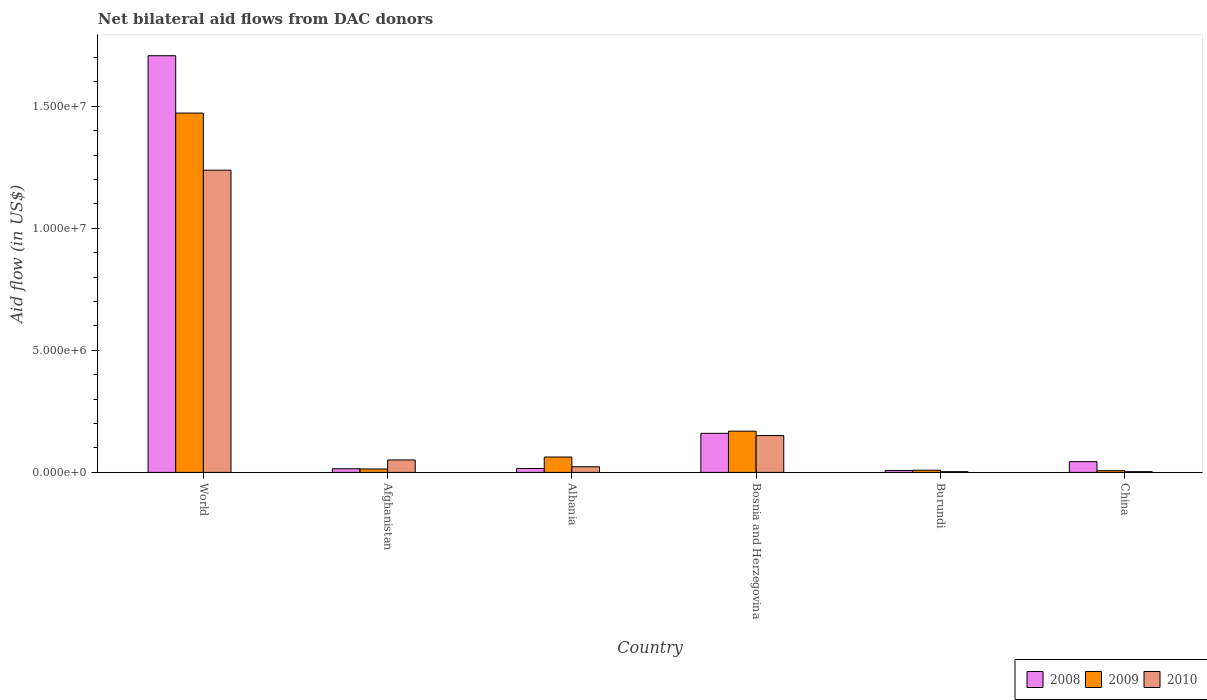How many different coloured bars are there?
Your answer should be compact. 3. Are the number of bars on each tick of the X-axis equal?
Provide a succinct answer. Yes. How many bars are there on the 1st tick from the right?
Make the answer very short. 3. What is the label of the 6th group of bars from the left?
Ensure brevity in your answer.  China. In how many cases, is the number of bars for a given country not equal to the number of legend labels?
Ensure brevity in your answer.  0. What is the net bilateral aid flow in 2009 in China?
Ensure brevity in your answer.  7.00e+04. Across all countries, what is the maximum net bilateral aid flow in 2010?
Your response must be concise. 1.24e+07. Across all countries, what is the minimum net bilateral aid flow in 2008?
Your answer should be very brief. 8.00e+04. In which country was the net bilateral aid flow in 2010 maximum?
Provide a succinct answer. World. In which country was the net bilateral aid flow in 2008 minimum?
Keep it short and to the point. Burundi. What is the total net bilateral aid flow in 2010 in the graph?
Your answer should be very brief. 1.47e+07. What is the difference between the net bilateral aid flow in 2009 in Bosnia and Herzegovina and that in Burundi?
Ensure brevity in your answer.  1.60e+06. What is the difference between the net bilateral aid flow in 2008 in Burundi and the net bilateral aid flow in 2010 in Bosnia and Herzegovina?
Offer a very short reply. -1.43e+06. What is the average net bilateral aid flow in 2008 per country?
Ensure brevity in your answer.  3.25e+06. In how many countries, is the net bilateral aid flow in 2008 greater than 3000000 US$?
Keep it short and to the point. 1. What is the ratio of the net bilateral aid flow in 2010 in Bosnia and Herzegovina to that in World?
Your answer should be very brief. 0.12. Is the net bilateral aid flow in 2010 in Bosnia and Herzegovina less than that in World?
Your answer should be very brief. Yes. What is the difference between the highest and the second highest net bilateral aid flow in 2008?
Your answer should be very brief. 1.55e+07. What is the difference between the highest and the lowest net bilateral aid flow in 2009?
Make the answer very short. 1.46e+07. Is the sum of the net bilateral aid flow in 2009 in Albania and Burundi greater than the maximum net bilateral aid flow in 2008 across all countries?
Provide a short and direct response. No. What does the 2nd bar from the left in China represents?
Offer a terse response. 2009. What does the 3rd bar from the right in World represents?
Offer a terse response. 2008. How many bars are there?
Give a very brief answer. 18. What is the difference between two consecutive major ticks on the Y-axis?
Your answer should be very brief. 5.00e+06. Does the graph contain any zero values?
Offer a terse response. No. How are the legend labels stacked?
Offer a terse response. Horizontal. What is the title of the graph?
Your answer should be compact. Net bilateral aid flows from DAC donors. What is the label or title of the Y-axis?
Keep it short and to the point. Aid flow (in US$). What is the Aid flow (in US$) of 2008 in World?
Give a very brief answer. 1.71e+07. What is the Aid flow (in US$) of 2009 in World?
Your answer should be compact. 1.47e+07. What is the Aid flow (in US$) in 2010 in World?
Provide a short and direct response. 1.24e+07. What is the Aid flow (in US$) of 2008 in Afghanistan?
Your answer should be compact. 1.50e+05. What is the Aid flow (in US$) of 2010 in Afghanistan?
Keep it short and to the point. 5.10e+05. What is the Aid flow (in US$) of 2009 in Albania?
Offer a terse response. 6.30e+05. What is the Aid flow (in US$) of 2010 in Albania?
Offer a terse response. 2.30e+05. What is the Aid flow (in US$) of 2008 in Bosnia and Herzegovina?
Your response must be concise. 1.60e+06. What is the Aid flow (in US$) of 2009 in Bosnia and Herzegovina?
Your answer should be compact. 1.69e+06. What is the Aid flow (in US$) in 2010 in Bosnia and Herzegovina?
Offer a very short reply. 1.51e+06. What is the Aid flow (in US$) of 2009 in Burundi?
Your answer should be compact. 9.00e+04. What is the Aid flow (in US$) of 2010 in Burundi?
Ensure brevity in your answer.  3.00e+04. What is the Aid flow (in US$) in 2008 in China?
Your answer should be very brief. 4.40e+05. What is the Aid flow (in US$) of 2009 in China?
Provide a succinct answer. 7.00e+04. Across all countries, what is the maximum Aid flow (in US$) in 2008?
Your answer should be compact. 1.71e+07. Across all countries, what is the maximum Aid flow (in US$) in 2009?
Provide a short and direct response. 1.47e+07. Across all countries, what is the maximum Aid flow (in US$) in 2010?
Offer a terse response. 1.24e+07. Across all countries, what is the minimum Aid flow (in US$) of 2008?
Provide a short and direct response. 8.00e+04. What is the total Aid flow (in US$) of 2008 in the graph?
Make the answer very short. 1.95e+07. What is the total Aid flow (in US$) of 2009 in the graph?
Offer a terse response. 1.73e+07. What is the total Aid flow (in US$) of 2010 in the graph?
Provide a succinct answer. 1.47e+07. What is the difference between the Aid flow (in US$) in 2008 in World and that in Afghanistan?
Your answer should be very brief. 1.69e+07. What is the difference between the Aid flow (in US$) in 2009 in World and that in Afghanistan?
Make the answer very short. 1.46e+07. What is the difference between the Aid flow (in US$) in 2010 in World and that in Afghanistan?
Your response must be concise. 1.19e+07. What is the difference between the Aid flow (in US$) of 2008 in World and that in Albania?
Your answer should be compact. 1.69e+07. What is the difference between the Aid flow (in US$) in 2009 in World and that in Albania?
Your answer should be very brief. 1.41e+07. What is the difference between the Aid flow (in US$) in 2010 in World and that in Albania?
Provide a short and direct response. 1.22e+07. What is the difference between the Aid flow (in US$) of 2008 in World and that in Bosnia and Herzegovina?
Keep it short and to the point. 1.55e+07. What is the difference between the Aid flow (in US$) of 2009 in World and that in Bosnia and Herzegovina?
Offer a terse response. 1.30e+07. What is the difference between the Aid flow (in US$) of 2010 in World and that in Bosnia and Herzegovina?
Your answer should be compact. 1.09e+07. What is the difference between the Aid flow (in US$) of 2008 in World and that in Burundi?
Provide a short and direct response. 1.70e+07. What is the difference between the Aid flow (in US$) of 2009 in World and that in Burundi?
Give a very brief answer. 1.46e+07. What is the difference between the Aid flow (in US$) of 2010 in World and that in Burundi?
Your answer should be very brief. 1.24e+07. What is the difference between the Aid flow (in US$) in 2008 in World and that in China?
Offer a terse response. 1.66e+07. What is the difference between the Aid flow (in US$) of 2009 in World and that in China?
Ensure brevity in your answer.  1.46e+07. What is the difference between the Aid flow (in US$) of 2010 in World and that in China?
Give a very brief answer. 1.24e+07. What is the difference between the Aid flow (in US$) of 2008 in Afghanistan and that in Albania?
Provide a short and direct response. -10000. What is the difference between the Aid flow (in US$) in 2009 in Afghanistan and that in Albania?
Keep it short and to the point. -4.90e+05. What is the difference between the Aid flow (in US$) in 2008 in Afghanistan and that in Bosnia and Herzegovina?
Make the answer very short. -1.45e+06. What is the difference between the Aid flow (in US$) of 2009 in Afghanistan and that in Bosnia and Herzegovina?
Your answer should be compact. -1.55e+06. What is the difference between the Aid flow (in US$) in 2010 in Afghanistan and that in Bosnia and Herzegovina?
Provide a short and direct response. -1.00e+06. What is the difference between the Aid flow (in US$) in 2008 in Afghanistan and that in Burundi?
Provide a succinct answer. 7.00e+04. What is the difference between the Aid flow (in US$) of 2009 in Afghanistan and that in Burundi?
Provide a succinct answer. 5.00e+04. What is the difference between the Aid flow (in US$) in 2009 in Afghanistan and that in China?
Provide a short and direct response. 7.00e+04. What is the difference between the Aid flow (in US$) in 2010 in Afghanistan and that in China?
Your response must be concise. 4.80e+05. What is the difference between the Aid flow (in US$) in 2008 in Albania and that in Bosnia and Herzegovina?
Your answer should be very brief. -1.44e+06. What is the difference between the Aid flow (in US$) of 2009 in Albania and that in Bosnia and Herzegovina?
Offer a very short reply. -1.06e+06. What is the difference between the Aid flow (in US$) of 2010 in Albania and that in Bosnia and Herzegovina?
Your response must be concise. -1.28e+06. What is the difference between the Aid flow (in US$) of 2008 in Albania and that in Burundi?
Ensure brevity in your answer.  8.00e+04. What is the difference between the Aid flow (in US$) of 2009 in Albania and that in Burundi?
Ensure brevity in your answer.  5.40e+05. What is the difference between the Aid flow (in US$) of 2010 in Albania and that in Burundi?
Provide a succinct answer. 2.00e+05. What is the difference between the Aid flow (in US$) of 2008 in Albania and that in China?
Provide a short and direct response. -2.80e+05. What is the difference between the Aid flow (in US$) of 2009 in Albania and that in China?
Make the answer very short. 5.60e+05. What is the difference between the Aid flow (in US$) in 2010 in Albania and that in China?
Your response must be concise. 2.00e+05. What is the difference between the Aid flow (in US$) in 2008 in Bosnia and Herzegovina and that in Burundi?
Ensure brevity in your answer.  1.52e+06. What is the difference between the Aid flow (in US$) in 2009 in Bosnia and Herzegovina and that in Burundi?
Ensure brevity in your answer.  1.60e+06. What is the difference between the Aid flow (in US$) of 2010 in Bosnia and Herzegovina and that in Burundi?
Your answer should be very brief. 1.48e+06. What is the difference between the Aid flow (in US$) of 2008 in Bosnia and Herzegovina and that in China?
Provide a short and direct response. 1.16e+06. What is the difference between the Aid flow (in US$) of 2009 in Bosnia and Herzegovina and that in China?
Provide a short and direct response. 1.62e+06. What is the difference between the Aid flow (in US$) of 2010 in Bosnia and Herzegovina and that in China?
Ensure brevity in your answer.  1.48e+06. What is the difference between the Aid flow (in US$) of 2008 in Burundi and that in China?
Offer a very short reply. -3.60e+05. What is the difference between the Aid flow (in US$) of 2009 in Burundi and that in China?
Provide a short and direct response. 2.00e+04. What is the difference between the Aid flow (in US$) in 2008 in World and the Aid flow (in US$) in 2009 in Afghanistan?
Offer a very short reply. 1.69e+07. What is the difference between the Aid flow (in US$) of 2008 in World and the Aid flow (in US$) of 2010 in Afghanistan?
Provide a short and direct response. 1.66e+07. What is the difference between the Aid flow (in US$) of 2009 in World and the Aid flow (in US$) of 2010 in Afghanistan?
Your response must be concise. 1.42e+07. What is the difference between the Aid flow (in US$) of 2008 in World and the Aid flow (in US$) of 2009 in Albania?
Your response must be concise. 1.64e+07. What is the difference between the Aid flow (in US$) of 2008 in World and the Aid flow (in US$) of 2010 in Albania?
Provide a succinct answer. 1.68e+07. What is the difference between the Aid flow (in US$) of 2009 in World and the Aid flow (in US$) of 2010 in Albania?
Your response must be concise. 1.45e+07. What is the difference between the Aid flow (in US$) in 2008 in World and the Aid flow (in US$) in 2009 in Bosnia and Herzegovina?
Your response must be concise. 1.54e+07. What is the difference between the Aid flow (in US$) of 2008 in World and the Aid flow (in US$) of 2010 in Bosnia and Herzegovina?
Your answer should be compact. 1.56e+07. What is the difference between the Aid flow (in US$) of 2009 in World and the Aid flow (in US$) of 2010 in Bosnia and Herzegovina?
Your answer should be compact. 1.32e+07. What is the difference between the Aid flow (in US$) of 2008 in World and the Aid flow (in US$) of 2009 in Burundi?
Make the answer very short. 1.70e+07. What is the difference between the Aid flow (in US$) of 2008 in World and the Aid flow (in US$) of 2010 in Burundi?
Your answer should be very brief. 1.70e+07. What is the difference between the Aid flow (in US$) of 2009 in World and the Aid flow (in US$) of 2010 in Burundi?
Ensure brevity in your answer.  1.47e+07. What is the difference between the Aid flow (in US$) of 2008 in World and the Aid flow (in US$) of 2009 in China?
Offer a terse response. 1.70e+07. What is the difference between the Aid flow (in US$) in 2008 in World and the Aid flow (in US$) in 2010 in China?
Provide a short and direct response. 1.70e+07. What is the difference between the Aid flow (in US$) of 2009 in World and the Aid flow (in US$) of 2010 in China?
Your response must be concise. 1.47e+07. What is the difference between the Aid flow (in US$) in 2008 in Afghanistan and the Aid flow (in US$) in 2009 in Albania?
Your answer should be very brief. -4.80e+05. What is the difference between the Aid flow (in US$) in 2008 in Afghanistan and the Aid flow (in US$) in 2010 in Albania?
Keep it short and to the point. -8.00e+04. What is the difference between the Aid flow (in US$) in 2009 in Afghanistan and the Aid flow (in US$) in 2010 in Albania?
Make the answer very short. -9.00e+04. What is the difference between the Aid flow (in US$) in 2008 in Afghanistan and the Aid flow (in US$) in 2009 in Bosnia and Herzegovina?
Give a very brief answer. -1.54e+06. What is the difference between the Aid flow (in US$) of 2008 in Afghanistan and the Aid flow (in US$) of 2010 in Bosnia and Herzegovina?
Your answer should be very brief. -1.36e+06. What is the difference between the Aid flow (in US$) in 2009 in Afghanistan and the Aid flow (in US$) in 2010 in Bosnia and Herzegovina?
Provide a succinct answer. -1.37e+06. What is the difference between the Aid flow (in US$) in 2008 in Afghanistan and the Aid flow (in US$) in 2009 in Burundi?
Offer a terse response. 6.00e+04. What is the difference between the Aid flow (in US$) in 2009 in Afghanistan and the Aid flow (in US$) in 2010 in China?
Your answer should be very brief. 1.10e+05. What is the difference between the Aid flow (in US$) of 2008 in Albania and the Aid flow (in US$) of 2009 in Bosnia and Herzegovina?
Your answer should be compact. -1.53e+06. What is the difference between the Aid flow (in US$) of 2008 in Albania and the Aid flow (in US$) of 2010 in Bosnia and Herzegovina?
Provide a succinct answer. -1.35e+06. What is the difference between the Aid flow (in US$) in 2009 in Albania and the Aid flow (in US$) in 2010 in Bosnia and Herzegovina?
Ensure brevity in your answer.  -8.80e+05. What is the difference between the Aid flow (in US$) of 2008 in Albania and the Aid flow (in US$) of 2009 in Burundi?
Your answer should be very brief. 7.00e+04. What is the difference between the Aid flow (in US$) in 2008 in Albania and the Aid flow (in US$) in 2009 in China?
Your answer should be very brief. 9.00e+04. What is the difference between the Aid flow (in US$) of 2009 in Albania and the Aid flow (in US$) of 2010 in China?
Give a very brief answer. 6.00e+05. What is the difference between the Aid flow (in US$) of 2008 in Bosnia and Herzegovina and the Aid flow (in US$) of 2009 in Burundi?
Your answer should be compact. 1.51e+06. What is the difference between the Aid flow (in US$) in 2008 in Bosnia and Herzegovina and the Aid flow (in US$) in 2010 in Burundi?
Your response must be concise. 1.57e+06. What is the difference between the Aid flow (in US$) in 2009 in Bosnia and Herzegovina and the Aid flow (in US$) in 2010 in Burundi?
Give a very brief answer. 1.66e+06. What is the difference between the Aid flow (in US$) in 2008 in Bosnia and Herzegovina and the Aid flow (in US$) in 2009 in China?
Make the answer very short. 1.53e+06. What is the difference between the Aid flow (in US$) of 2008 in Bosnia and Herzegovina and the Aid flow (in US$) of 2010 in China?
Your answer should be compact. 1.57e+06. What is the difference between the Aid flow (in US$) of 2009 in Bosnia and Herzegovina and the Aid flow (in US$) of 2010 in China?
Offer a very short reply. 1.66e+06. What is the difference between the Aid flow (in US$) in 2008 in Burundi and the Aid flow (in US$) in 2009 in China?
Ensure brevity in your answer.  10000. What is the difference between the Aid flow (in US$) of 2009 in Burundi and the Aid flow (in US$) of 2010 in China?
Ensure brevity in your answer.  6.00e+04. What is the average Aid flow (in US$) of 2008 per country?
Provide a short and direct response. 3.25e+06. What is the average Aid flow (in US$) of 2009 per country?
Offer a terse response. 2.89e+06. What is the average Aid flow (in US$) of 2010 per country?
Your answer should be compact. 2.45e+06. What is the difference between the Aid flow (in US$) in 2008 and Aid flow (in US$) in 2009 in World?
Provide a succinct answer. 2.35e+06. What is the difference between the Aid flow (in US$) in 2008 and Aid flow (in US$) in 2010 in World?
Ensure brevity in your answer.  4.69e+06. What is the difference between the Aid flow (in US$) in 2009 and Aid flow (in US$) in 2010 in World?
Your response must be concise. 2.34e+06. What is the difference between the Aid flow (in US$) of 2008 and Aid flow (in US$) of 2010 in Afghanistan?
Keep it short and to the point. -3.60e+05. What is the difference between the Aid flow (in US$) of 2009 and Aid flow (in US$) of 2010 in Afghanistan?
Make the answer very short. -3.70e+05. What is the difference between the Aid flow (in US$) in 2008 and Aid flow (in US$) in 2009 in Albania?
Give a very brief answer. -4.70e+05. What is the difference between the Aid flow (in US$) of 2008 and Aid flow (in US$) of 2009 in Bosnia and Herzegovina?
Provide a short and direct response. -9.00e+04. What is the difference between the Aid flow (in US$) in 2008 and Aid flow (in US$) in 2010 in Bosnia and Herzegovina?
Make the answer very short. 9.00e+04. What is the difference between the Aid flow (in US$) in 2008 and Aid flow (in US$) in 2009 in Burundi?
Your answer should be very brief. -10000. What is the difference between the Aid flow (in US$) of 2008 and Aid flow (in US$) of 2010 in Burundi?
Ensure brevity in your answer.  5.00e+04. What is the difference between the Aid flow (in US$) in 2009 and Aid flow (in US$) in 2010 in Burundi?
Provide a short and direct response. 6.00e+04. What is the difference between the Aid flow (in US$) in 2008 and Aid flow (in US$) in 2009 in China?
Keep it short and to the point. 3.70e+05. What is the ratio of the Aid flow (in US$) of 2008 in World to that in Afghanistan?
Your answer should be compact. 113.8. What is the ratio of the Aid flow (in US$) of 2009 in World to that in Afghanistan?
Your answer should be compact. 105.14. What is the ratio of the Aid flow (in US$) of 2010 in World to that in Afghanistan?
Your answer should be compact. 24.27. What is the ratio of the Aid flow (in US$) in 2008 in World to that in Albania?
Ensure brevity in your answer.  106.69. What is the ratio of the Aid flow (in US$) of 2009 in World to that in Albania?
Your response must be concise. 23.37. What is the ratio of the Aid flow (in US$) of 2010 in World to that in Albania?
Offer a terse response. 53.83. What is the ratio of the Aid flow (in US$) in 2008 in World to that in Bosnia and Herzegovina?
Offer a very short reply. 10.67. What is the ratio of the Aid flow (in US$) in 2009 in World to that in Bosnia and Herzegovina?
Your response must be concise. 8.71. What is the ratio of the Aid flow (in US$) in 2010 in World to that in Bosnia and Herzegovina?
Your answer should be very brief. 8.2. What is the ratio of the Aid flow (in US$) of 2008 in World to that in Burundi?
Give a very brief answer. 213.38. What is the ratio of the Aid flow (in US$) of 2009 in World to that in Burundi?
Give a very brief answer. 163.56. What is the ratio of the Aid flow (in US$) in 2010 in World to that in Burundi?
Ensure brevity in your answer.  412.67. What is the ratio of the Aid flow (in US$) in 2008 in World to that in China?
Offer a very short reply. 38.8. What is the ratio of the Aid flow (in US$) in 2009 in World to that in China?
Offer a terse response. 210.29. What is the ratio of the Aid flow (in US$) in 2010 in World to that in China?
Your response must be concise. 412.67. What is the ratio of the Aid flow (in US$) of 2008 in Afghanistan to that in Albania?
Your answer should be compact. 0.94. What is the ratio of the Aid flow (in US$) in 2009 in Afghanistan to that in Albania?
Ensure brevity in your answer.  0.22. What is the ratio of the Aid flow (in US$) of 2010 in Afghanistan to that in Albania?
Provide a short and direct response. 2.22. What is the ratio of the Aid flow (in US$) in 2008 in Afghanistan to that in Bosnia and Herzegovina?
Your response must be concise. 0.09. What is the ratio of the Aid flow (in US$) in 2009 in Afghanistan to that in Bosnia and Herzegovina?
Keep it short and to the point. 0.08. What is the ratio of the Aid flow (in US$) in 2010 in Afghanistan to that in Bosnia and Herzegovina?
Your answer should be very brief. 0.34. What is the ratio of the Aid flow (in US$) in 2008 in Afghanistan to that in Burundi?
Keep it short and to the point. 1.88. What is the ratio of the Aid flow (in US$) in 2009 in Afghanistan to that in Burundi?
Offer a terse response. 1.56. What is the ratio of the Aid flow (in US$) of 2008 in Afghanistan to that in China?
Your answer should be very brief. 0.34. What is the ratio of the Aid flow (in US$) in 2009 in Afghanistan to that in China?
Keep it short and to the point. 2. What is the ratio of the Aid flow (in US$) of 2010 in Afghanistan to that in China?
Make the answer very short. 17. What is the ratio of the Aid flow (in US$) of 2009 in Albania to that in Bosnia and Herzegovina?
Make the answer very short. 0.37. What is the ratio of the Aid flow (in US$) of 2010 in Albania to that in Bosnia and Herzegovina?
Your answer should be very brief. 0.15. What is the ratio of the Aid flow (in US$) in 2009 in Albania to that in Burundi?
Your answer should be very brief. 7. What is the ratio of the Aid flow (in US$) of 2010 in Albania to that in Burundi?
Make the answer very short. 7.67. What is the ratio of the Aid flow (in US$) of 2008 in Albania to that in China?
Make the answer very short. 0.36. What is the ratio of the Aid flow (in US$) in 2010 in Albania to that in China?
Your answer should be very brief. 7.67. What is the ratio of the Aid flow (in US$) in 2008 in Bosnia and Herzegovina to that in Burundi?
Provide a succinct answer. 20. What is the ratio of the Aid flow (in US$) in 2009 in Bosnia and Herzegovina to that in Burundi?
Give a very brief answer. 18.78. What is the ratio of the Aid flow (in US$) of 2010 in Bosnia and Herzegovina to that in Burundi?
Offer a very short reply. 50.33. What is the ratio of the Aid flow (in US$) of 2008 in Bosnia and Herzegovina to that in China?
Your response must be concise. 3.64. What is the ratio of the Aid flow (in US$) of 2009 in Bosnia and Herzegovina to that in China?
Offer a very short reply. 24.14. What is the ratio of the Aid flow (in US$) of 2010 in Bosnia and Herzegovina to that in China?
Make the answer very short. 50.33. What is the ratio of the Aid flow (in US$) in 2008 in Burundi to that in China?
Your answer should be compact. 0.18. What is the ratio of the Aid flow (in US$) of 2009 in Burundi to that in China?
Your answer should be very brief. 1.29. What is the difference between the highest and the second highest Aid flow (in US$) of 2008?
Your answer should be compact. 1.55e+07. What is the difference between the highest and the second highest Aid flow (in US$) of 2009?
Ensure brevity in your answer.  1.30e+07. What is the difference between the highest and the second highest Aid flow (in US$) in 2010?
Give a very brief answer. 1.09e+07. What is the difference between the highest and the lowest Aid flow (in US$) in 2008?
Your answer should be compact. 1.70e+07. What is the difference between the highest and the lowest Aid flow (in US$) of 2009?
Provide a short and direct response. 1.46e+07. What is the difference between the highest and the lowest Aid flow (in US$) in 2010?
Make the answer very short. 1.24e+07. 